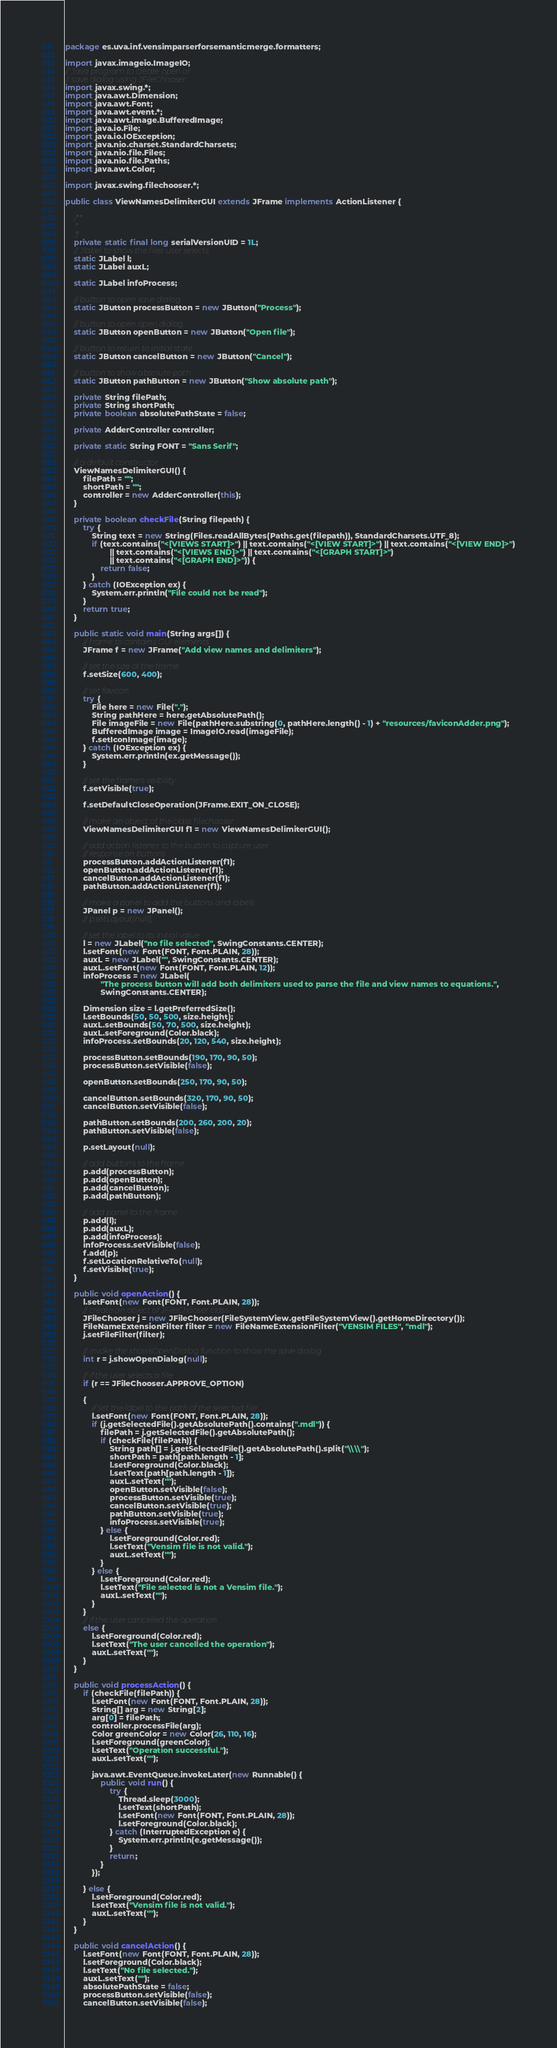Convert code to text. <code><loc_0><loc_0><loc_500><loc_500><_Java_>package es.uva.inf.vensimparserforsemanticmerge.formatters;

import javax.imageio.ImageIO;
// Java program to create open or 
// save dialog using JFileChooser 
import javax.swing.*;
import java.awt.Dimension;
import java.awt.Font;
import java.awt.event.*;
import java.awt.image.BufferedImage;
import java.io.File;
import java.io.IOException;
import java.nio.charset.StandardCharsets;
import java.nio.file.Files;
import java.nio.file.Paths;
import java.awt.Color;

import javax.swing.filechooser.*;

public class ViewNamesDelimiterGUI extends JFrame implements ActionListener {

    /**
     *
     */
    private static final long serialVersionUID = 1L;
    // Jlabel to show the files user selects
    static JLabel l;
    static JLabel auxL;

    static JLabel infoProcess;

    // button to open save dialog
    static JButton processButton = new JButton("Process");

    // button to open open dialog
    static JButton openButton = new JButton("Open file");

    // button to return to initial state
    static JButton cancelButton = new JButton("Cancel");

    // button to show absolute path
    static JButton pathButton = new JButton("Show absolute path");

    private String filePath;
    private String shortPath;
    private boolean absolutePathState = false;

    private AdderController controller;

    private static String FONT = "Sans Serif";

    // a default constructor
    ViewNamesDelimiterGUI() {
        filePath = "";
        shortPath = "";
        controller = new AdderController(this);
    }

    private boolean checkFile(String filepath) {
        try {
            String text = new String(Files.readAllBytes(Paths.get(filepath)), StandardCharsets.UTF_8);
            if (text.contains("<[VIEWS START]>") || text.contains("<[VIEW START]>") || text.contains("<[VIEW END]>")
                    || text.contains("<[VIEWS END]>") || text.contains("<[GRAPH START]>")
                    || text.contains("<[GRAPH END]>")) {
                return false;
            }
        } catch (IOException ex) {
            System.err.println("File could not be read");
        }
        return true;
    }

    public static void main(String args[]) {
        // frame to contains GUI elements
        JFrame f = new JFrame("Add view names and delimiters");

        // set the size of the frame
        f.setSize(600, 400);

        // set favicon
        try {
            File here = new File(".");
            String pathHere = here.getAbsolutePath();
            File imageFile = new File(pathHere.substring(0, pathHere.length() - 1) + "resources/faviconAdder.png");
            BufferedImage image = ImageIO.read(imageFile);
            f.setIconImage(image);
        } catch (IOException ex) {
            System.err.println(ex.getMessage());
        }

        // set the frame's visibility
        f.setVisible(true);

        f.setDefaultCloseOperation(JFrame.EXIT_ON_CLOSE);

        // make an object of the class filechooser
        ViewNamesDelimiterGUI f1 = new ViewNamesDelimiterGUI();

        // add action listener to the button to capture user
        // response on buttons
        processButton.addActionListener(f1);
        openButton.addActionListener(f1);
        cancelButton.addActionListener(f1);
        pathButton.addActionListener(f1);

        // make a panel to add the buttons and labels
        JPanel p = new JPanel();
        // p.setLayout(null);

        // set the label to its initial value
        l = new JLabel("no file selected", SwingConstants.CENTER);
        l.setFont(new Font(FONT, Font.PLAIN, 28));
        auxL = new JLabel("", SwingConstants.CENTER);
        auxL.setFont(new Font(FONT, Font.PLAIN, 12));
        infoProcess = new JLabel(
                "The process button will add both delimiters used to parse the file and view names to equations.",
                SwingConstants.CENTER);

        Dimension size = l.getPreferredSize();
        l.setBounds(50, 50, 500, size.height);
        auxL.setBounds(50, 70, 500, size.height);
        auxL.setForeground(Color.black);
        infoProcess.setBounds(20, 120, 540, size.height);

        processButton.setBounds(190, 170, 90, 50);
        processButton.setVisible(false);

        openButton.setBounds(250, 170, 90, 50);

        cancelButton.setBounds(320, 170, 90, 50);
        cancelButton.setVisible(false);

        pathButton.setBounds(200, 260, 200, 20);
        pathButton.setVisible(false);

        p.setLayout(null);

        // add buttons to the frame
        p.add(processButton);
        p.add(openButton);
        p.add(cancelButton);
        p.add(pathButton);

        // add panel to the frame
        p.add(l);
        p.add(auxL);
        p.add(infoProcess);
        infoProcess.setVisible(false);
        f.add(p);
        f.setLocationRelativeTo(null);
        f.setVisible(true);
    }

    public void openAction() {
        l.setFont(new Font(FONT, Font.PLAIN, 28));
        // create an object of JFileChooser class
        JFileChooser j = new JFileChooser(FileSystemView.getFileSystemView().getHomeDirectory());
        FileNameExtensionFilter filter = new FileNameExtensionFilter("VENSIM FILES", "mdl");
        j.setFileFilter(filter);

        // invoke the showsOpenDialog function to show the save dialog
        int r = j.showOpenDialog(null);

        // if the user selects a file
        if (r == JFileChooser.APPROVE_OPTION)

        {
            // set the label to the path of the selected file
            l.setFont(new Font(FONT, Font.PLAIN, 28));
            if (j.getSelectedFile().getAbsolutePath().contains(".mdl")) {
                filePath = j.getSelectedFile().getAbsolutePath();
                if (checkFile(filePath)) {
                    String path[] = j.getSelectedFile().getAbsolutePath().split("\\\\");
                    shortPath = path[path.length - 1];
                    l.setForeground(Color.black);
                    l.setText(path[path.length - 1]);
                    auxL.setText("");
                    openButton.setVisible(false);
                    processButton.setVisible(true);
                    cancelButton.setVisible(true);
                    pathButton.setVisible(true);
                    infoProcess.setVisible(true);
                } else {
                    l.setForeground(Color.red);
                    l.setText("Vensim file is not valid.");
                    auxL.setText("");
                }
            } else {
                l.setForeground(Color.red);
                l.setText("File selected is not a Vensim file.");
                auxL.setText("");
            }
        }
        // if the user cancelled the operation
        else {
            l.setForeground(Color.red);
            l.setText("The user cancelled the operation");
            auxL.setText("");
        }
    }

    public void processAction() {
        if (checkFile(filePath)) {
            l.setFont(new Font(FONT, Font.PLAIN, 28));
            String[] arg = new String[2];
            arg[0] = filePath;
            controller.processFile(arg);
            Color greenColor = new Color(26, 110, 16);
            l.setForeground(greenColor);
            l.setText("Operation successful.");
            auxL.setText("");

            java.awt.EventQueue.invokeLater(new Runnable() {
                public void run() {
                    try {
                        Thread.sleep(3000);
                        l.setText(shortPath);
                        l.setFont(new Font(FONT, Font.PLAIN, 28));
                        l.setForeground(Color.black);
                    } catch (InterruptedException e) {
                        System.err.println(e.getMessage());
                    }
                    return;
                }
            });

        } else {
            l.setForeground(Color.red);
            l.setText("Vensim file is not valid.");
            auxL.setText("");
        }
    }

    public void cancelAction() {
        l.setFont(new Font(FONT, Font.PLAIN, 28));
        l.setForeground(Color.black);
        l.setText("No file selected.");
        auxL.setText("");
        absolutePathState = false;
        processButton.setVisible(false);
        cancelButton.setVisible(false);</code> 